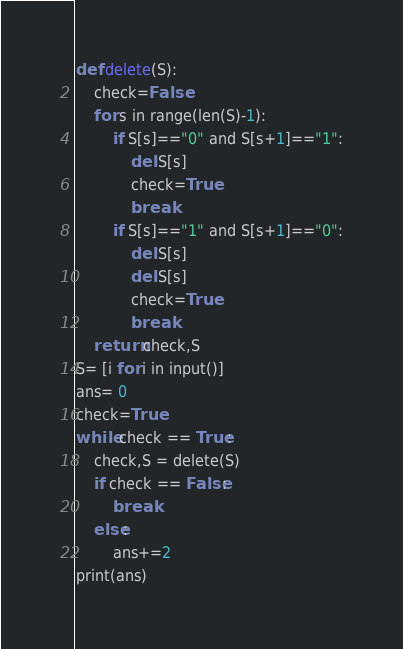<code> <loc_0><loc_0><loc_500><loc_500><_Python_>def delete(S):
    check=False
    for s in range(len(S)-1):
        if S[s]=="0" and S[s+1]=="1":
            del S[s]
            check=True
            break
        if S[s]=="1" and S[s+1]=="0":
            del S[s]
            del S[s]
            check=True
            break
    return check,S
S= [i for i in input()]
ans= 0
check=True
while check == True:
    check,S = delete(S)
    if check == False:
        break
    else:
        ans+=2
print(ans)</code> 